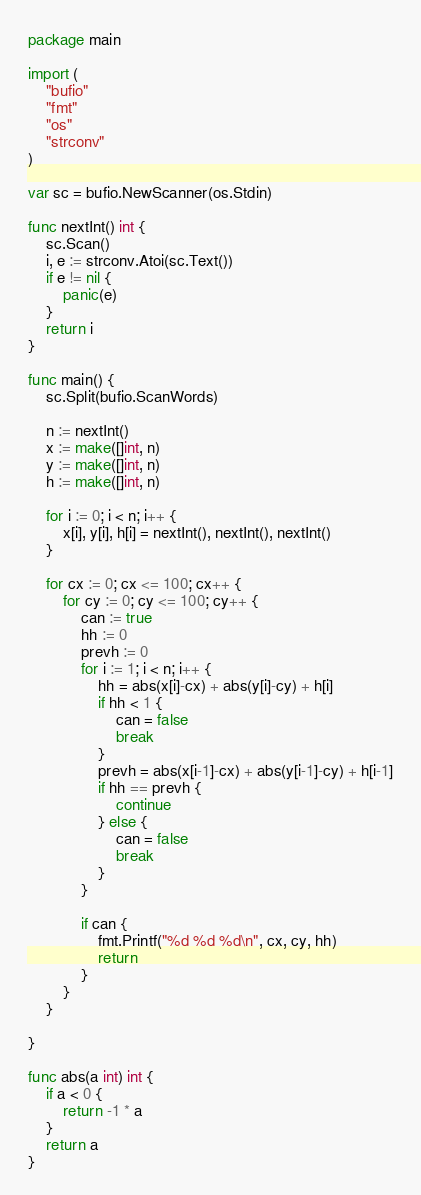<code> <loc_0><loc_0><loc_500><loc_500><_Go_>package main

import (
	"bufio"
	"fmt"
	"os"
	"strconv"
)

var sc = bufio.NewScanner(os.Stdin)

func nextInt() int {
	sc.Scan()
	i, e := strconv.Atoi(sc.Text())
	if e != nil {
		panic(e)
	}
	return i
}

func main() {
	sc.Split(bufio.ScanWords)

	n := nextInt()
	x := make([]int, n)
	y := make([]int, n)
	h := make([]int, n)

	for i := 0; i < n; i++ {
		x[i], y[i], h[i] = nextInt(), nextInt(), nextInt()
	}

	for cx := 0; cx <= 100; cx++ {
		for cy := 0; cy <= 100; cy++ {
			can := true
			hh := 0
			prevh := 0
			for i := 1; i < n; i++ {
				hh = abs(x[i]-cx) + abs(y[i]-cy) + h[i]
				if hh < 1 {
					can = false
					break
				}
				prevh = abs(x[i-1]-cx) + abs(y[i-1]-cy) + h[i-1]
				if hh == prevh {
					continue
				} else {
					can = false
					break
				}
			}

			if can {
				fmt.Printf("%d %d %d\n", cx, cy, hh)
				return
			}
		}
	}

}

func abs(a int) int {
	if a < 0 {
		return -1 * a
	}
	return a
}
</code> 